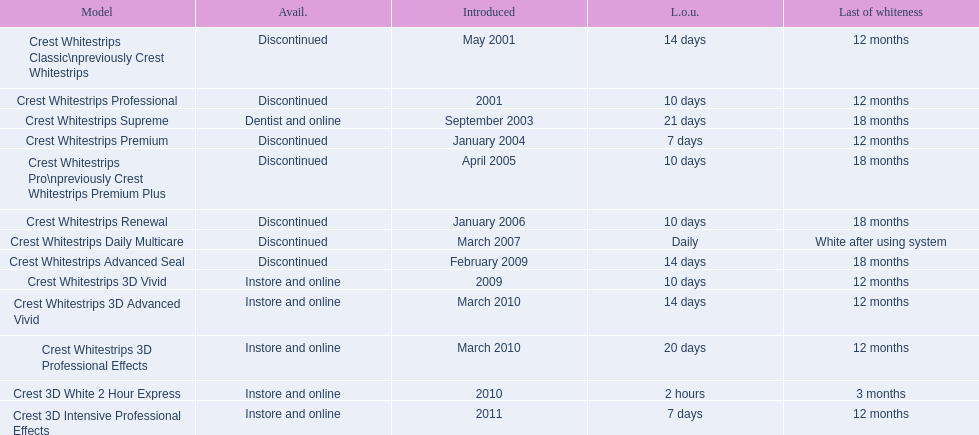Which of these products are discontinued? Crest Whitestrips Classic\npreviously Crest Whitestrips, Crest Whitestrips Professional, Crest Whitestrips Premium, Crest Whitestrips Pro\npreviously Crest Whitestrips Premium Plus, Crest Whitestrips Renewal, Crest Whitestrips Daily Multicare, Crest Whitestrips Advanced Seal. Which of these products have a 14 day length of use? Crest Whitestrips Classic\npreviously Crest Whitestrips, Crest Whitestrips Advanced Seal. Which of these products was introduced in 2009? Crest Whitestrips Advanced Seal. 